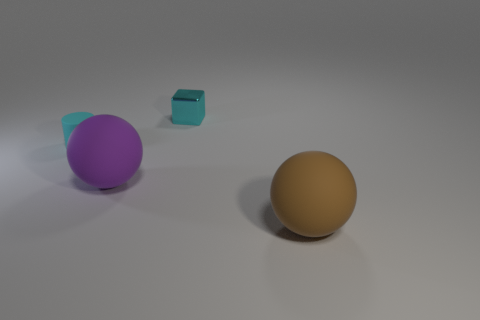There is another object that is the same shape as the large purple matte thing; what color is it?
Ensure brevity in your answer.  Brown. How many cyan things are either blocks or large spheres?
Your answer should be compact. 1. What material is the small cyan thing to the right of the big sphere to the left of the cyan shiny block made of?
Provide a short and direct response. Metal. Is the shape of the cyan matte thing the same as the tiny shiny thing?
Your answer should be very brief. No. There is a shiny cube that is the same size as the cyan matte cylinder; what color is it?
Keep it short and to the point. Cyan. Are there any tiny matte cylinders of the same color as the cube?
Your answer should be compact. Yes. Are there any brown objects?
Provide a short and direct response. Yes. Is the material of the big ball behind the brown rubber thing the same as the tiny block?
Give a very brief answer. No. There is a matte cylinder that is the same color as the metallic thing; what size is it?
Your answer should be compact. Small. How many yellow rubber cylinders are the same size as the cyan cylinder?
Ensure brevity in your answer.  0. 